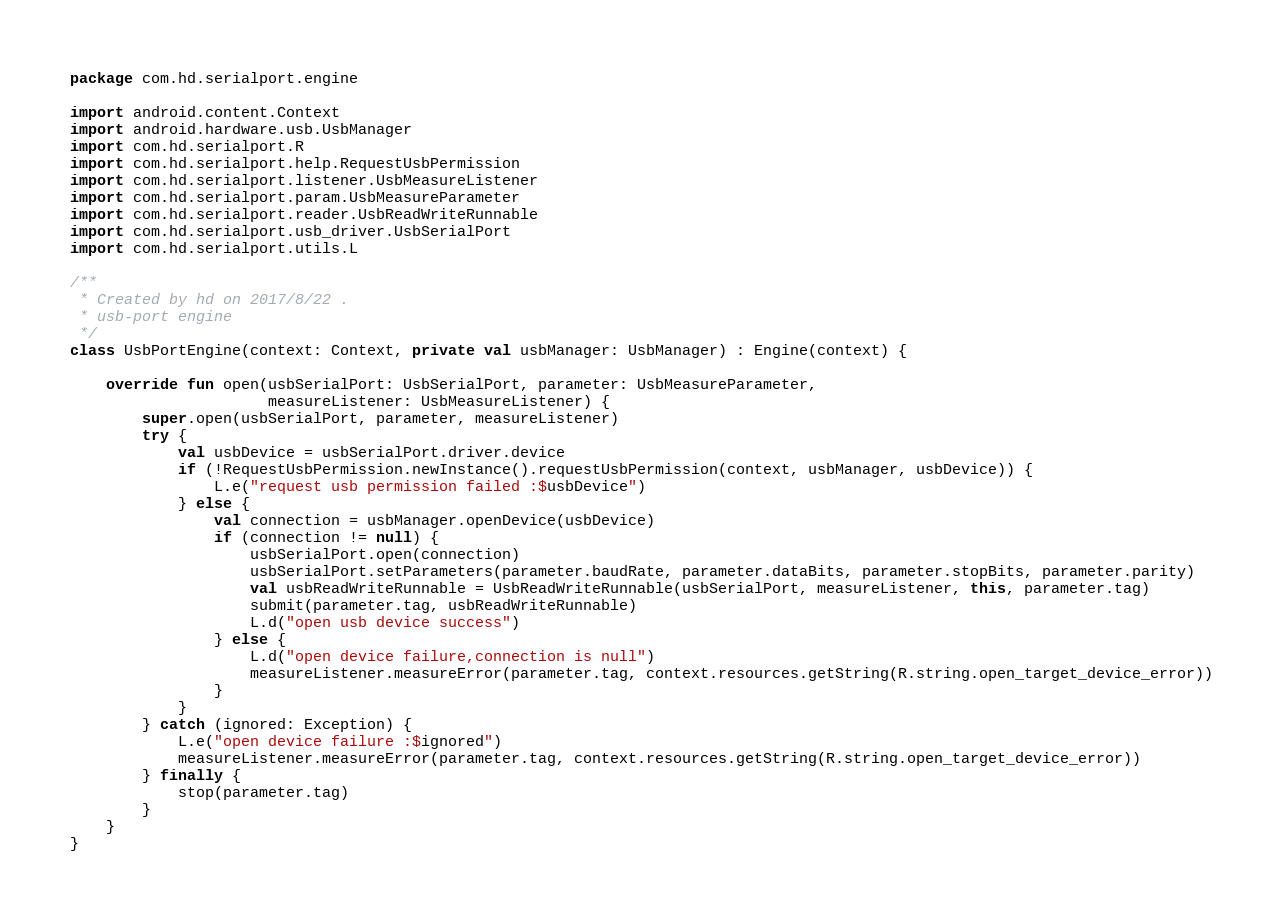<code> <loc_0><loc_0><loc_500><loc_500><_Kotlin_>package com.hd.serialport.engine

import android.content.Context
import android.hardware.usb.UsbManager
import com.hd.serialport.R
import com.hd.serialport.help.RequestUsbPermission
import com.hd.serialport.listener.UsbMeasureListener
import com.hd.serialport.param.UsbMeasureParameter
import com.hd.serialport.reader.UsbReadWriteRunnable
import com.hd.serialport.usb_driver.UsbSerialPort
import com.hd.serialport.utils.L

/**
 * Created by hd on 2017/8/22 .
 * usb-port engine
 */
class UsbPortEngine(context: Context, private val usbManager: UsbManager) : Engine(context) {
    
    override fun open(usbSerialPort: UsbSerialPort, parameter: UsbMeasureParameter,
                      measureListener: UsbMeasureListener) {
        super.open(usbSerialPort, parameter, measureListener)
        try {
            val usbDevice = usbSerialPort.driver.device
            if (!RequestUsbPermission.newInstance().requestUsbPermission(context, usbManager, usbDevice)) {
                L.e("request usb permission failed :$usbDevice")
            } else {
                val connection = usbManager.openDevice(usbDevice)
                if (connection != null) {
                    usbSerialPort.open(connection)
                    usbSerialPort.setParameters(parameter.baudRate, parameter.dataBits, parameter.stopBits, parameter.parity)
                    val usbReadWriteRunnable = UsbReadWriteRunnable(usbSerialPort, measureListener, this, parameter.tag)
                    submit(parameter.tag, usbReadWriteRunnable)
                    L.d("open usb device success")
                } else {
                    L.d("open device failure,connection is null")
                    measureListener.measureError(parameter.tag, context.resources.getString(R.string.open_target_device_error))
                }
            }
        } catch (ignored: Exception) {
            L.e("open device failure :$ignored")
            measureListener.measureError(parameter.tag, context.resources.getString(R.string.open_target_device_error))
        } finally {
            stop(parameter.tag)
        }
    }
}
</code> 